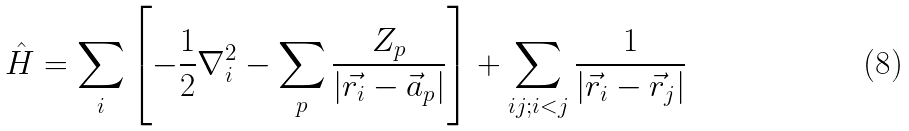<formula> <loc_0><loc_0><loc_500><loc_500>\hat { H } = \sum _ { i } \left [ - \frac { 1 } { 2 } \nabla ^ { 2 } _ { i } - \sum _ { p } \frac { Z _ { p } } { | \vec { r _ { i } } - \vec { a } _ { p } | } \right ] + \sum _ { i j ; i < j } \frac { 1 } { | \vec { r } _ { i } - \vec { r } _ { j } | }</formula> 